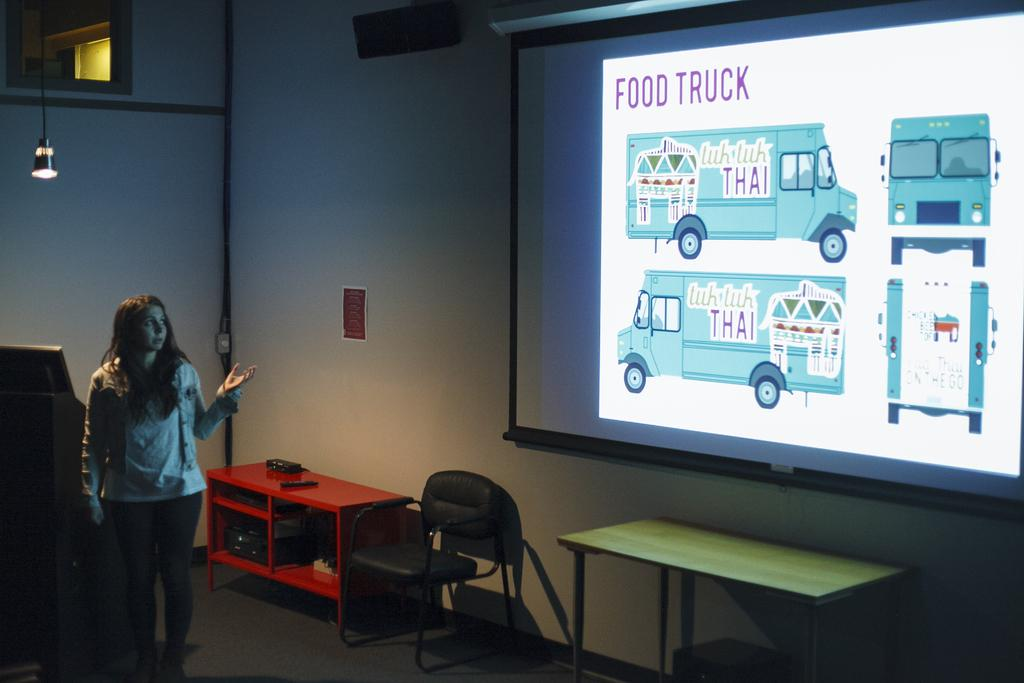Who is present in the image? There is a woman in the image. What is the woman doing in the image? The woman is standing and looking at a projector screen. Is the woman engaged in any activity in the image? Yes, the woman is talking. What furniture is visible in the image? There is a chair and tables in the image. What type of lighting is present in the image? There is a light hanging from the roof. Can you see any crackers on the tables in the image? There is no mention of crackers in the image, so we cannot determine if they are present or not. 